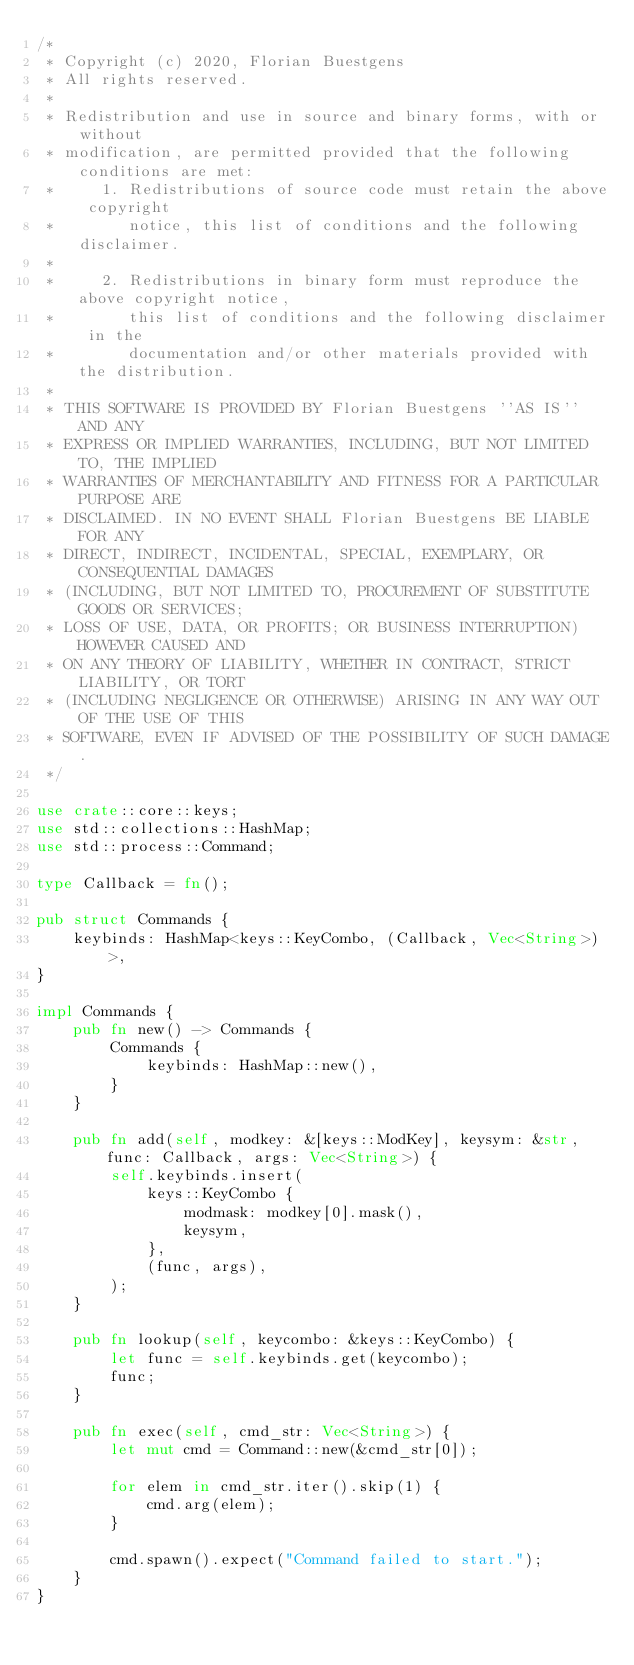<code> <loc_0><loc_0><loc_500><loc_500><_Rust_>/*
 * Copyright (c) 2020, Florian Buestgens
 * All rights reserved.
 *
 * Redistribution and use in source and binary forms, with or without
 * modification, are permitted provided that the following conditions are met:
 *     1. Redistributions of source code must retain the above copyright
 *        notice, this list of conditions and the following disclaimer.
 *
 *     2. Redistributions in binary form must reproduce the above copyright notice,
 *        this list of conditions and the following disclaimer in the
 *        documentation and/or other materials provided with the distribution.
 *
 * THIS SOFTWARE IS PROVIDED BY Florian Buestgens ''AS IS'' AND ANY
 * EXPRESS OR IMPLIED WARRANTIES, INCLUDING, BUT NOT LIMITED TO, THE IMPLIED
 * WARRANTIES OF MERCHANTABILITY AND FITNESS FOR A PARTICULAR PURPOSE ARE
 * DISCLAIMED. IN NO EVENT SHALL Florian Buestgens BE LIABLE FOR ANY
 * DIRECT, INDIRECT, INCIDENTAL, SPECIAL, EXEMPLARY, OR CONSEQUENTIAL DAMAGES
 * (INCLUDING, BUT NOT LIMITED TO, PROCUREMENT OF SUBSTITUTE GOODS OR SERVICES;
 * LOSS OF USE, DATA, OR PROFITS; OR BUSINESS INTERRUPTION) HOWEVER CAUSED AND
 * ON ANY THEORY OF LIABILITY, WHETHER IN CONTRACT, STRICT LIABILITY, OR TORT
 * (INCLUDING NEGLIGENCE OR OTHERWISE) ARISING IN ANY WAY OUT OF THE USE OF THIS
 * SOFTWARE, EVEN IF ADVISED OF THE POSSIBILITY OF SUCH DAMAGE.
 */

use crate::core::keys;
use std::collections::HashMap;
use std::process::Command;

type Callback = fn();

pub struct Commands {
    keybinds: HashMap<keys::KeyCombo, (Callback, Vec<String>)>,
}

impl Commands {
    pub fn new() -> Commands {
        Commands {
            keybinds: HashMap::new(),
        }
    }

    pub fn add(self, modkey: &[keys::ModKey], keysym: &str, func: Callback, args: Vec<String>) {
        self.keybinds.insert(
            keys::KeyCombo {
                modmask: modkey[0].mask(),
                keysym,
            },
            (func, args),
        );
    }

    pub fn lookup(self, keycombo: &keys::KeyCombo) {
        let func = self.keybinds.get(keycombo);
        func;
    }

    pub fn exec(self, cmd_str: Vec<String>) {
        let mut cmd = Command::new(&cmd_str[0]);

        for elem in cmd_str.iter().skip(1) {
            cmd.arg(elem);
        }

        cmd.spawn().expect("Command failed to start.");
    }
}
</code> 